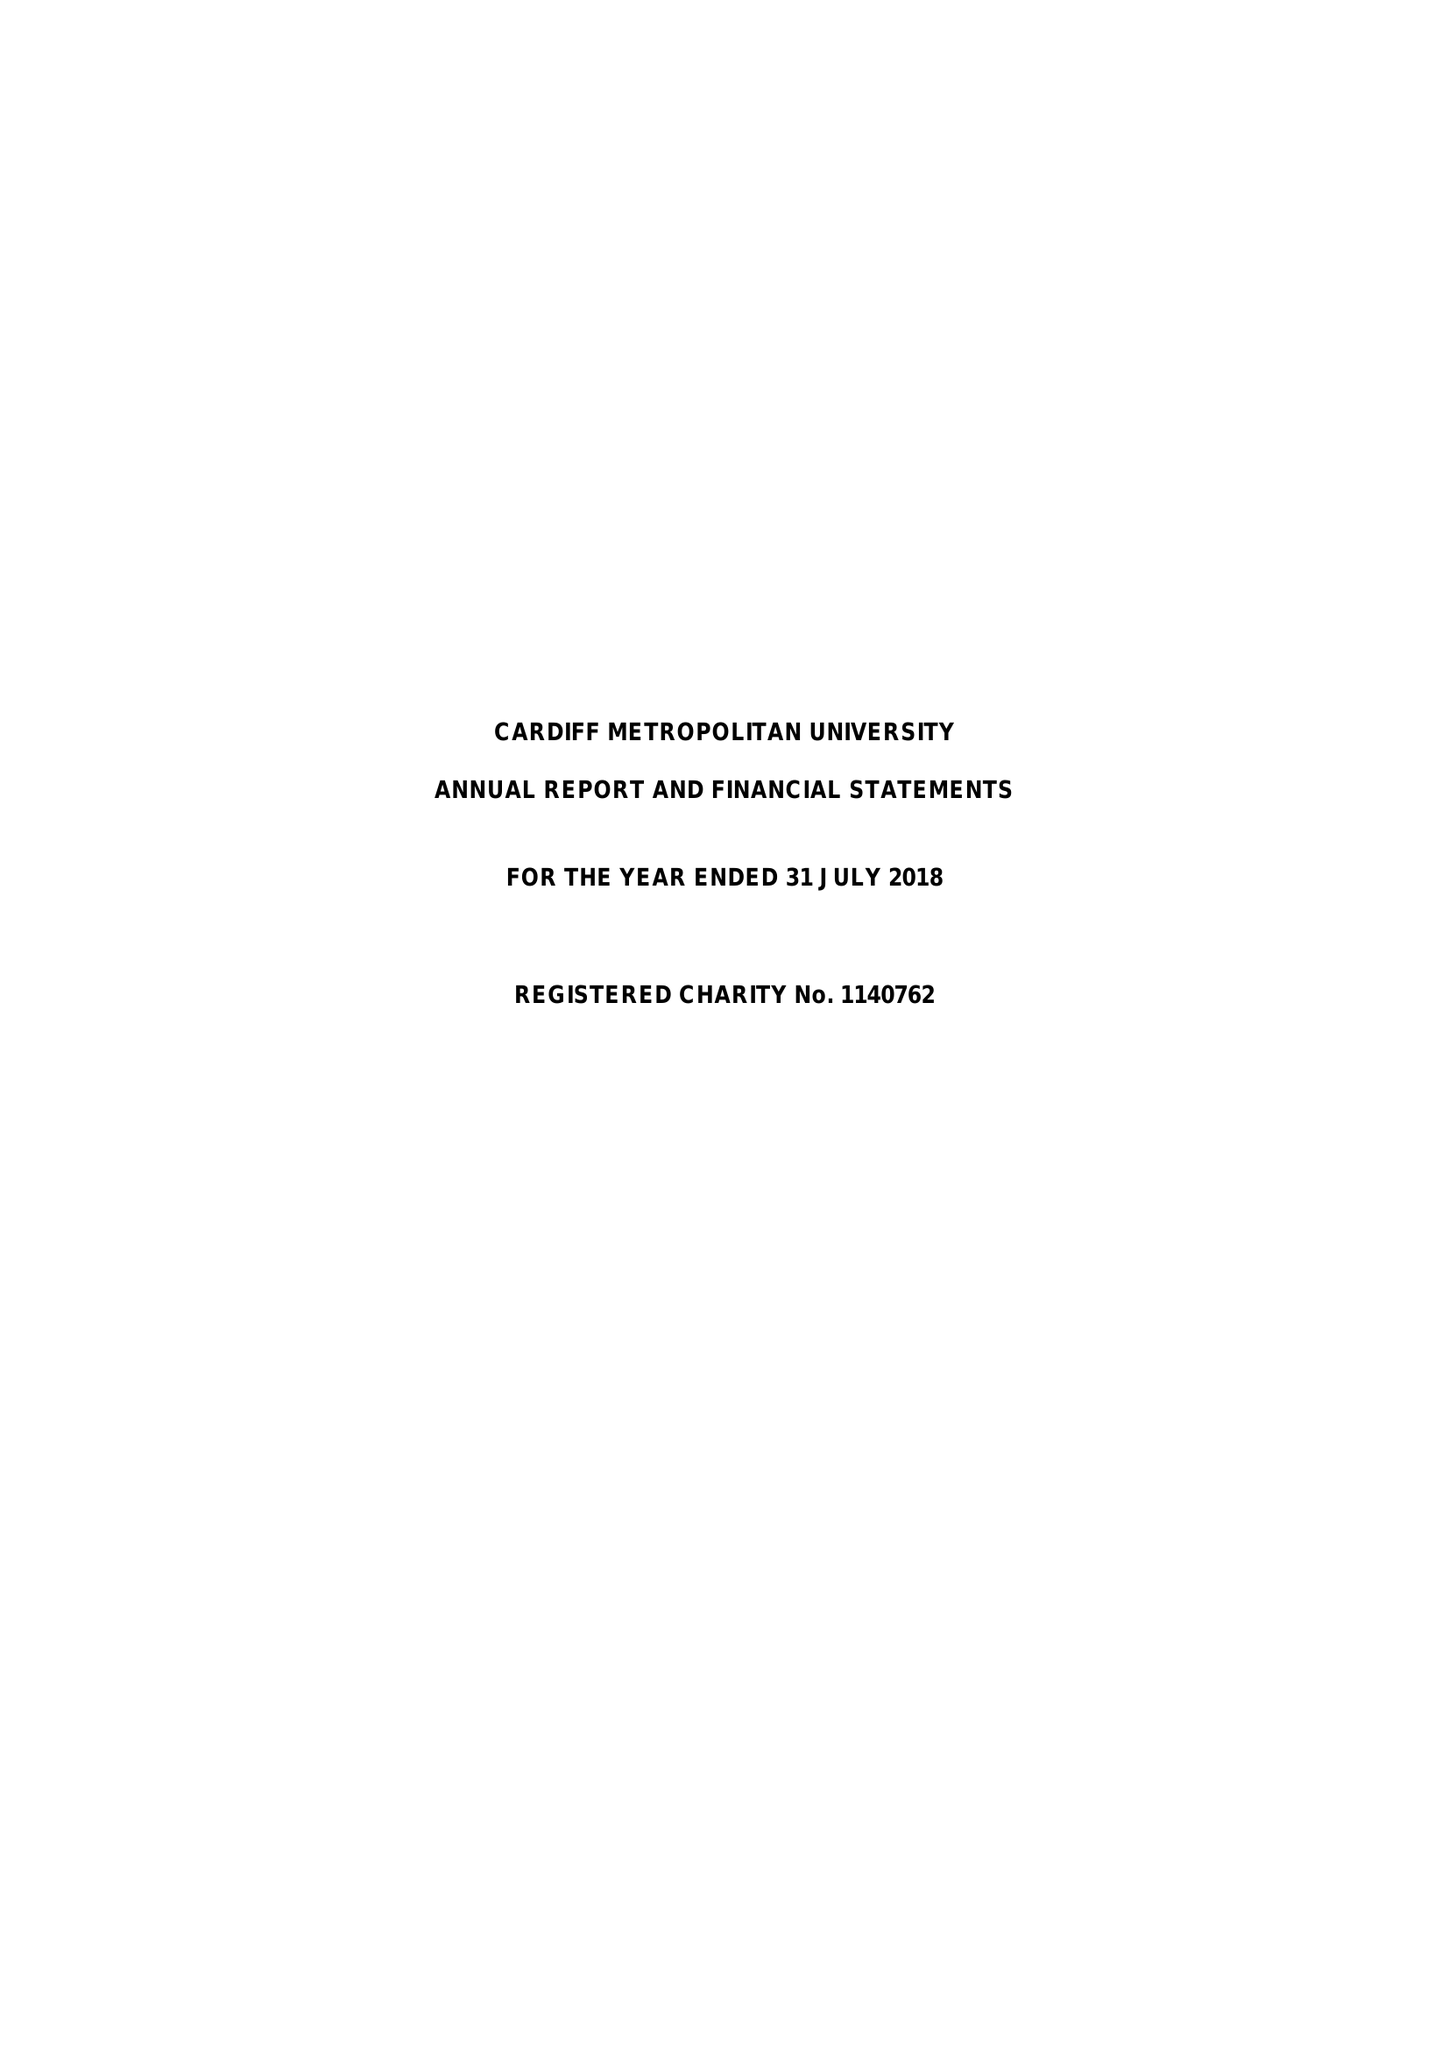What is the value for the address__street_line?
Answer the question using a single word or phrase. WESTERN AVENUE 